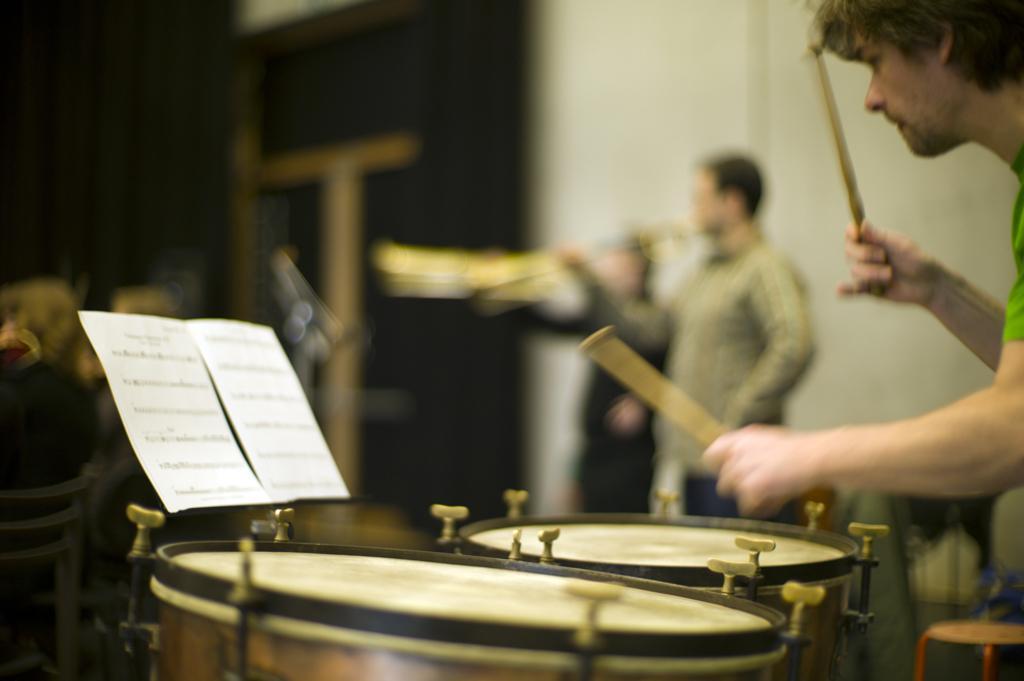Could you give a brief overview of what you see in this image? As we can see in the image there is a white color wall and three people. The man who is standing here is playing drums. 